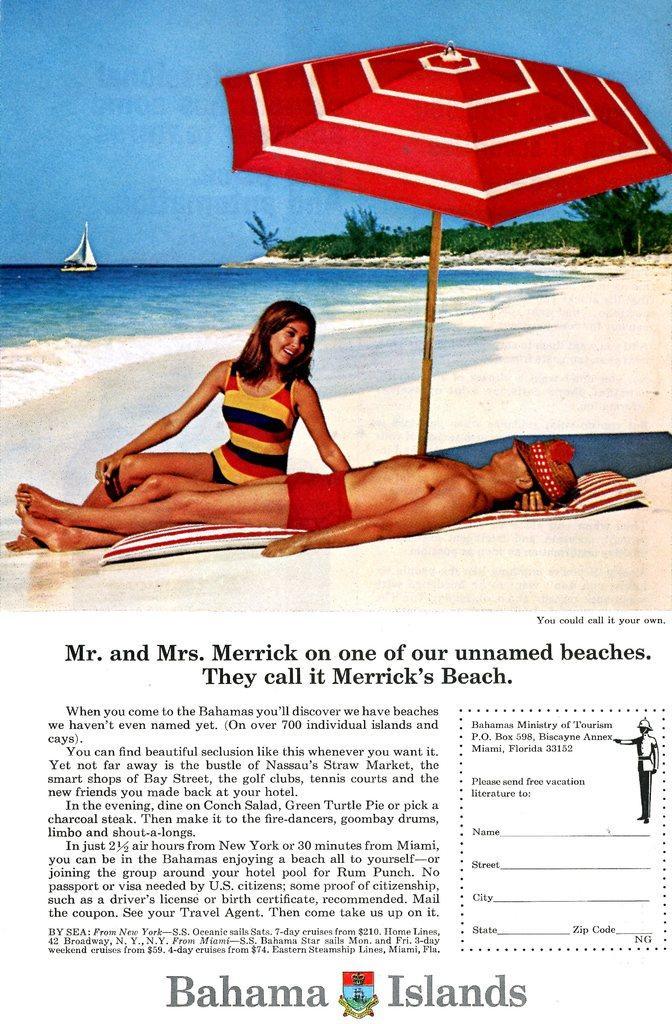Please provide a concise description of this image. It is a poster. In the poster a man is lying on sand. Behind him a woman is sitting and smiling and there is a umbrella. Top left side of the image there is water and boat. Top right side of the image there are some trees. Top of the image there is sky. 